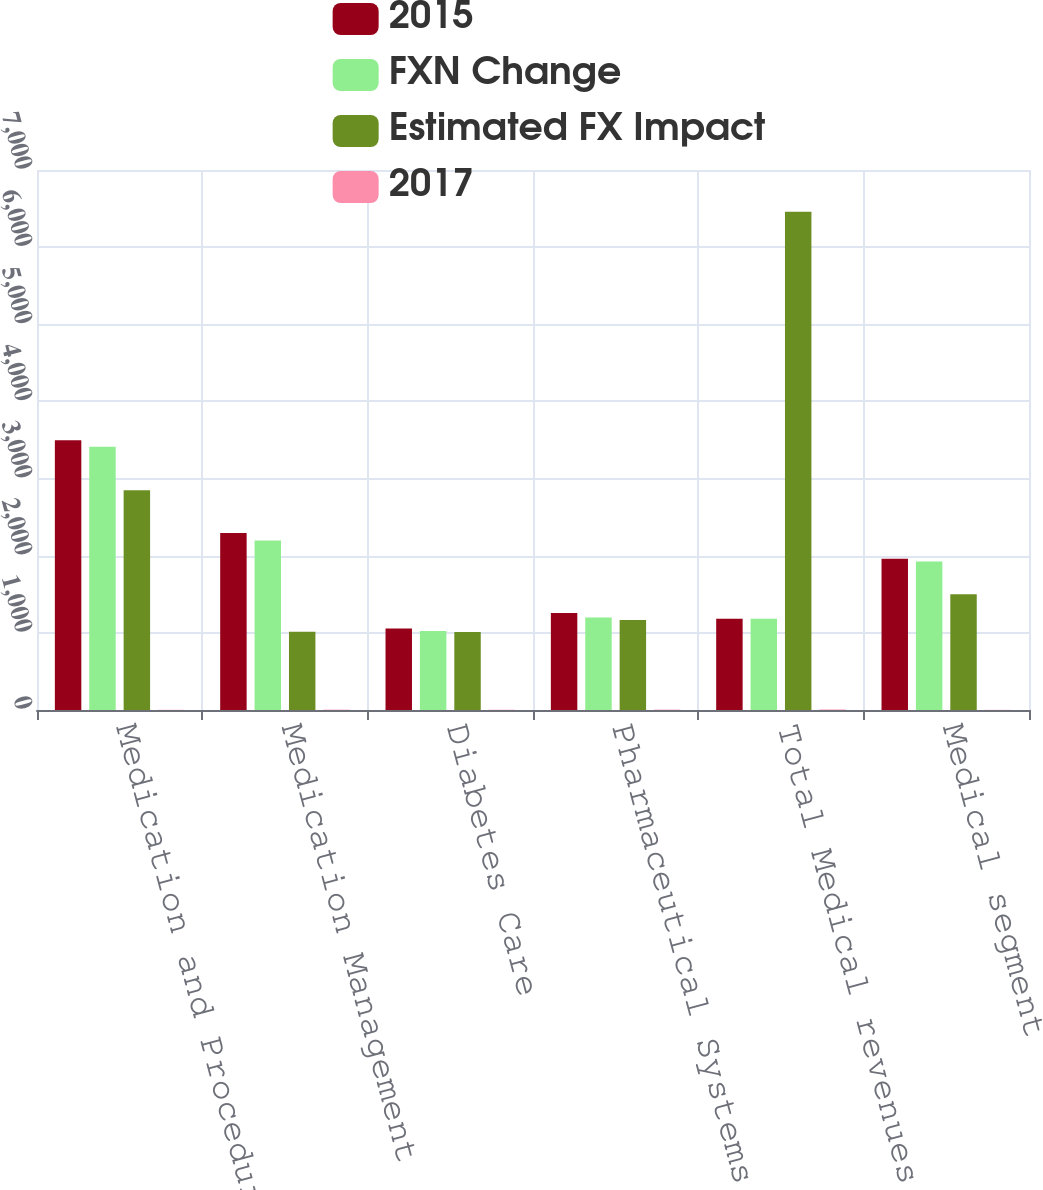Convert chart. <chart><loc_0><loc_0><loc_500><loc_500><stacked_bar_chart><ecel><fcel>Medication and Procedural<fcel>Medication Management<fcel>Diabetes Care<fcel>Pharmaceutical Systems<fcel>Total Medical revenues<fcel>Medical segment<nl><fcel>2015<fcel>3497<fcel>2295<fcel>1056<fcel>1256<fcel>1183<fcel>1960<nl><fcel>FXN Change<fcel>3413<fcel>2197<fcel>1023<fcel>1199<fcel>1183<fcel>1924<nl><fcel>Estimated FX Impact<fcel>2850<fcel>1015<fcel>1012<fcel>1167<fcel>6460<fcel>1499<nl><fcel>2017<fcel>2.5<fcel>4.4<fcel>3.3<fcel>4.8<fcel>6.4<fcel>1.9<nl></chart> 